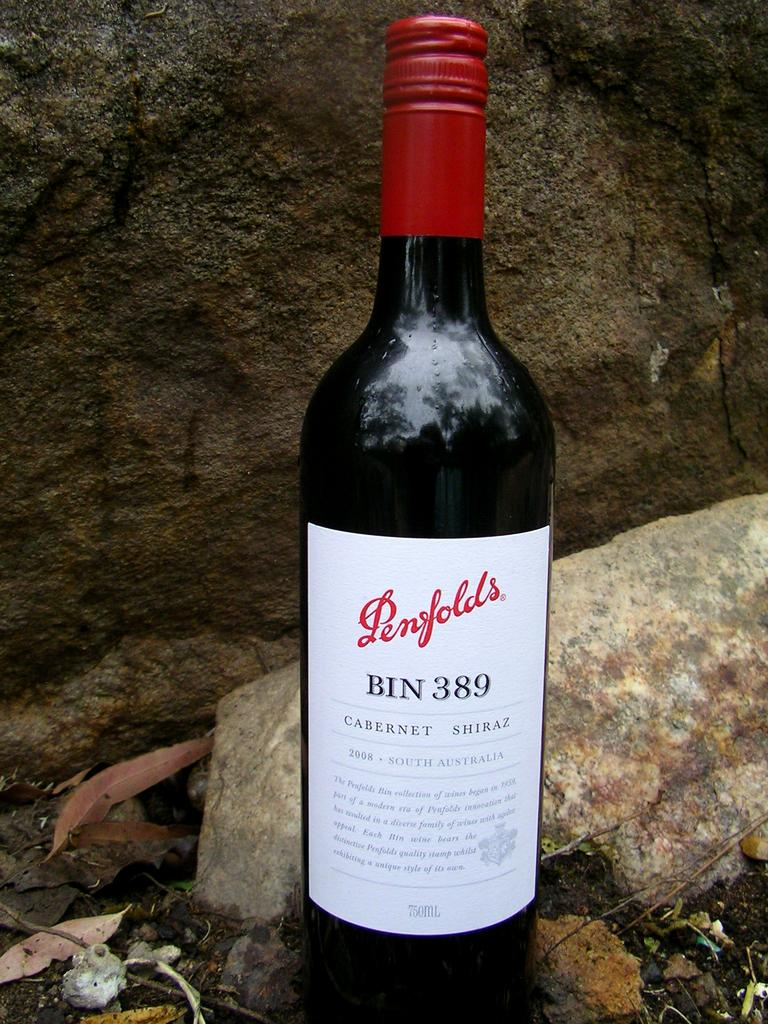<image>
Summarize the visual content of the image. A bottle of wine which has Bin 389 on the label. 